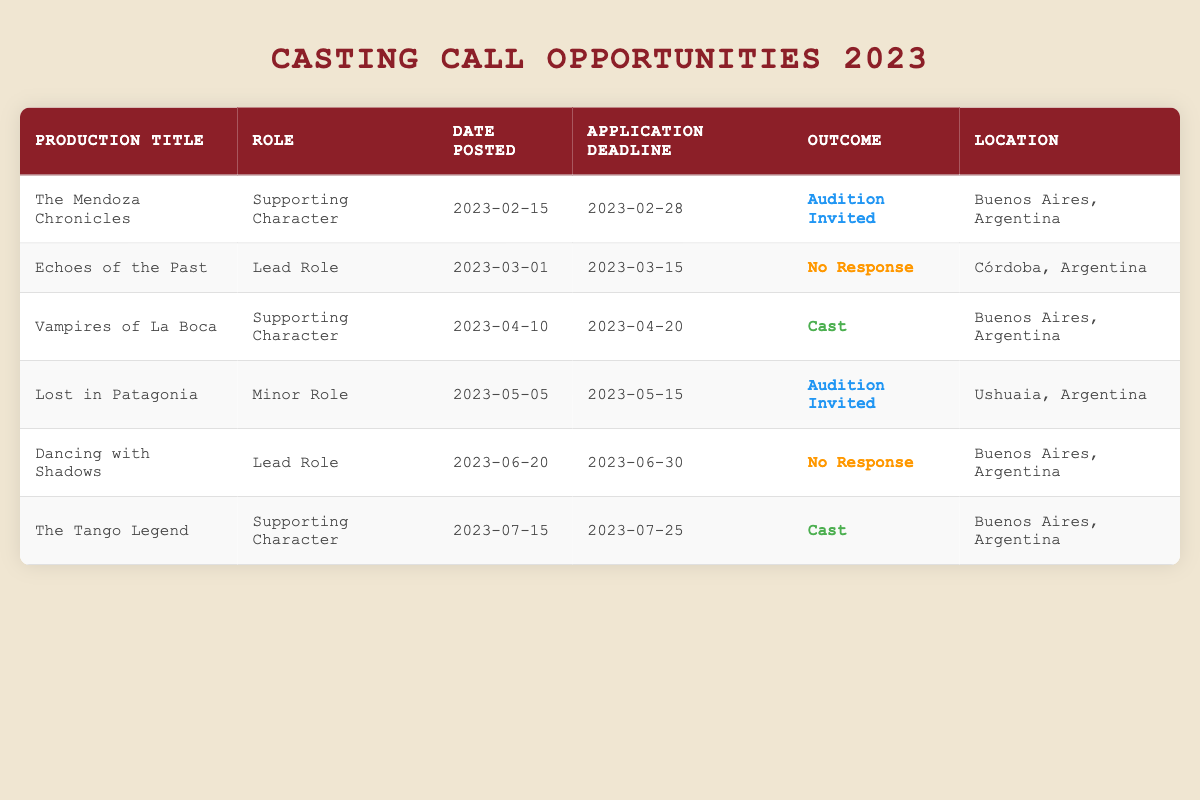What is the role associated with "The Mendoza Chronicles"? The role listed for "The Mendoza Chronicles" is "Supporting Character," as indicated in the table under the "Role" column for that specific production title.
Answer: Supporting Character How many casting calls resulted in a "No Response"? There are two casting calls with the outcome "No Response": "Echoes of the Past" and "Dancing with Shadows." Therefore, by counting these two, we find that the total is 2.
Answer: 2 In which city was "Vampires of La Boca" filmed? The production title "Vampires of La Boca" is located in "Buenos Aires, Argentina," which can be seen in the "Location" column corresponding to that title.
Answer: Buenos Aires, Argentina What is the most recent casting call application deadline? The most recent application deadline is "2023-07-25" for "The Tango Legend." By checking the application deadlines in the table and identifying the latest date, we can confirm this outcome.
Answer: 2023-07-25 Did any casting call lead to being cast, and if so, how many? Yes, there are two instances where the outcome is "Cast": for "Vampires of La Boca" and "The Tango Legend." By checking the "Outcome" column, we find these two occurrences.
Answer: Yes, 2 What percentage of casting calls resulted in an "Audition Invited"? There are 2 casting calls with an "Audition Invited" outcome (The Mendoza Chronicles and Lost in Patagonia) out of a total of 6 casting calls. The percentage is calculated by (2/6) * 100, which equals approximately 33.33%.
Answer: Approximately 33% What was the role type that received the most auditions invited? The role that received the most "Audition Invited" outcomes is "Supporting Character," appearing in two casting calls: "The Mendoza Chronicles" and "The Tango Legend." Both were invited for auditions, leading to this conclusion based on counting the occurrences in the role and outcome columns.
Answer: Supporting Character How many roles were categorized as "Lead Role" in casting calls? There were two instances of "Lead Role," which were found in "Echoes of the Past" and "Dancing with Shadows." By referring to the "Role" column, we can confirm these counts.
Answer: 2 Is there any casting call that is set in Ushuaia? Yes, there is one casting call set in Ushuaia, which is "Lost in Patagonia." By checking the "Location" column, we can verify this information.
Answer: Yes 